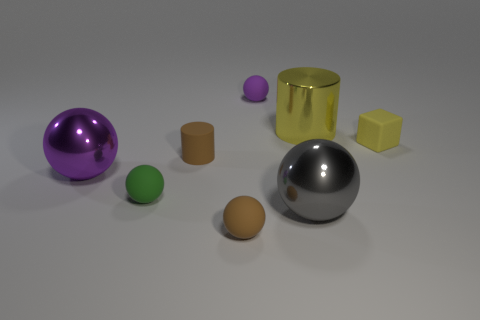Subtract 1 spheres. How many spheres are left? 4 Add 1 small purple things. How many objects exist? 9 Subtract all cylinders. How many objects are left? 6 Subtract 0 blue cylinders. How many objects are left? 8 Subtract all brown objects. Subtract all small purple balls. How many objects are left? 5 Add 5 small cylinders. How many small cylinders are left? 6 Add 4 large green rubber cylinders. How many large green rubber cylinders exist? 4 